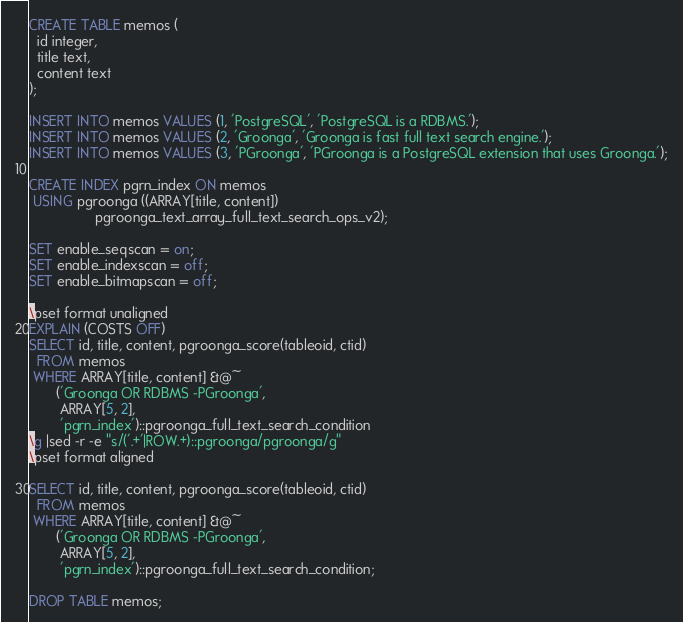<code> <loc_0><loc_0><loc_500><loc_500><_SQL_>CREATE TABLE memos (
  id integer,
  title text,
  content text
);

INSERT INTO memos VALUES (1, 'PostgreSQL', 'PostgreSQL is a RDBMS.');
INSERT INTO memos VALUES (2, 'Groonga', 'Groonga is fast full text search engine.');
INSERT INTO memos VALUES (3, 'PGroonga', 'PGroonga is a PostgreSQL extension that uses Groonga.');

CREATE INDEX pgrn_index ON memos
 USING pgroonga ((ARRAY[title, content])
                 pgroonga_text_array_full_text_search_ops_v2);

SET enable_seqscan = on;
SET enable_indexscan = off;
SET enable_bitmapscan = off;

\pset format unaligned
EXPLAIN (COSTS OFF)
SELECT id, title, content, pgroonga_score(tableoid, ctid)
  FROM memos
 WHERE ARRAY[title, content] &@~
       ('Groonga OR RDBMS -PGroonga',
        ARRAY[5, 2],
        'pgrn_index')::pgroonga_full_text_search_condition
\g |sed -r -e "s/('.+'|ROW.+)::pgroonga/pgroonga/g"
\pset format aligned

SELECT id, title, content, pgroonga_score(tableoid, ctid)
  FROM memos
 WHERE ARRAY[title, content] &@~
       ('Groonga OR RDBMS -PGroonga',
        ARRAY[5, 2],
        'pgrn_index')::pgroonga_full_text_search_condition;

DROP TABLE memos;
</code> 